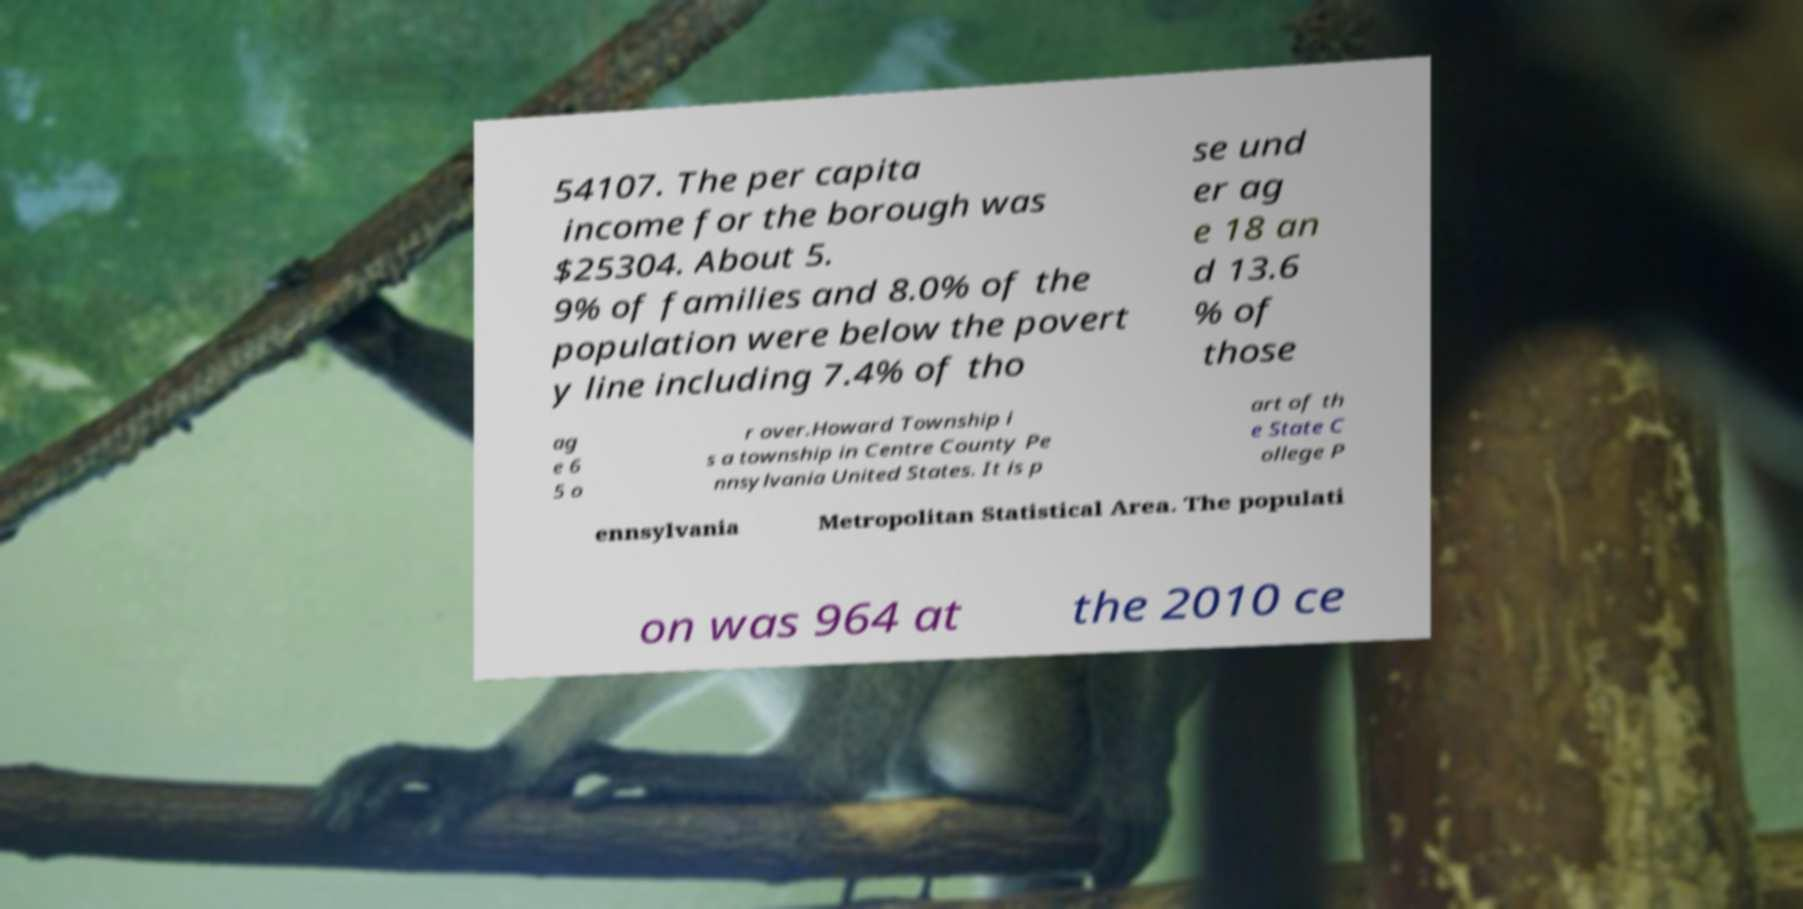There's text embedded in this image that I need extracted. Can you transcribe it verbatim? 54107. The per capita income for the borough was $25304. About 5. 9% of families and 8.0% of the population were below the povert y line including 7.4% of tho se und er ag e 18 an d 13.6 % of those ag e 6 5 o r over.Howard Township i s a township in Centre County Pe nnsylvania United States. It is p art of th e State C ollege P ennsylvania Metropolitan Statistical Area. The populati on was 964 at the 2010 ce 